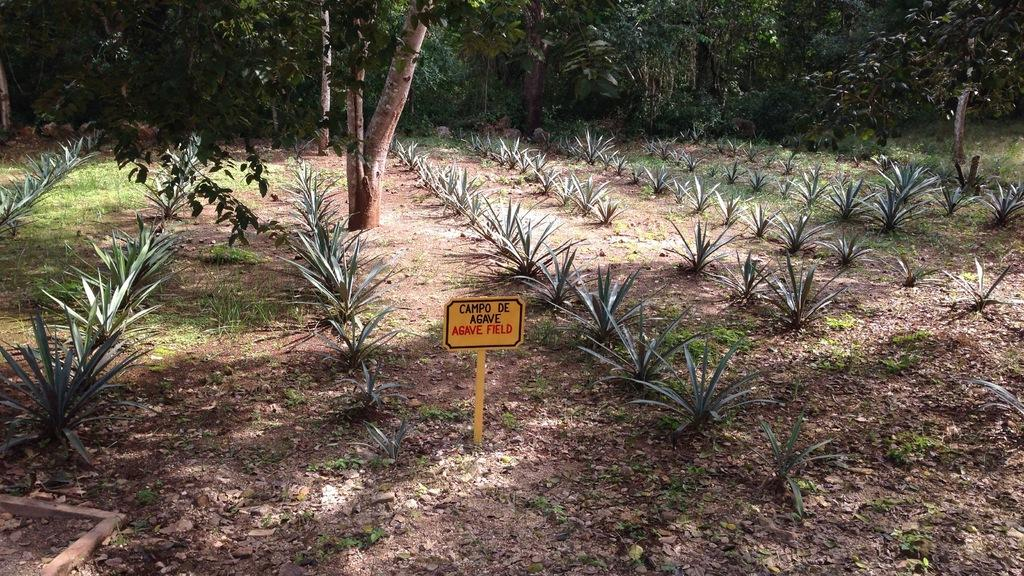What is the setting of the image? The image appears to be taken in a field. What can be seen on the ground in the image? There are small plants on the ground. What is visible in the background of the image? There are many trees in the background. What type of corn can be seen growing in the field in the image? There is no corn visible in the image; only small plants are present on the ground. How many pins are holding the sheet in the image? There is no sheet or pins present in the image. 